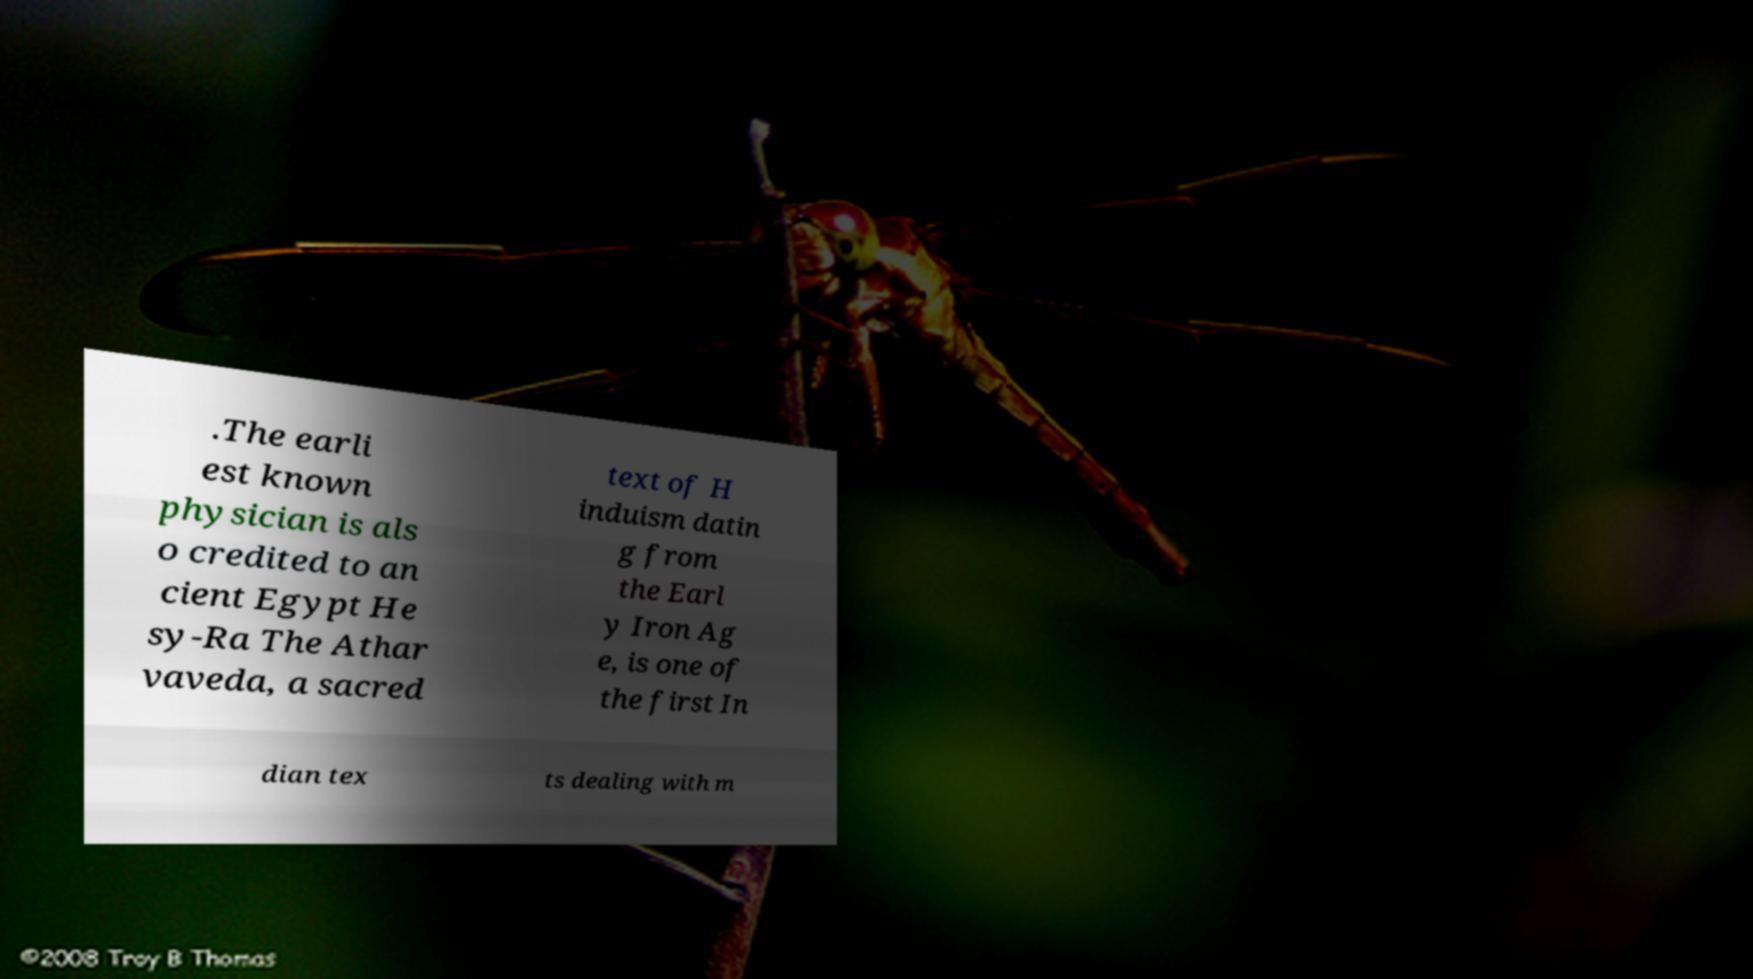For documentation purposes, I need the text within this image transcribed. Could you provide that? .The earli est known physician is als o credited to an cient Egypt He sy-Ra The Athar vaveda, a sacred text of H induism datin g from the Earl y Iron Ag e, is one of the first In dian tex ts dealing with m 